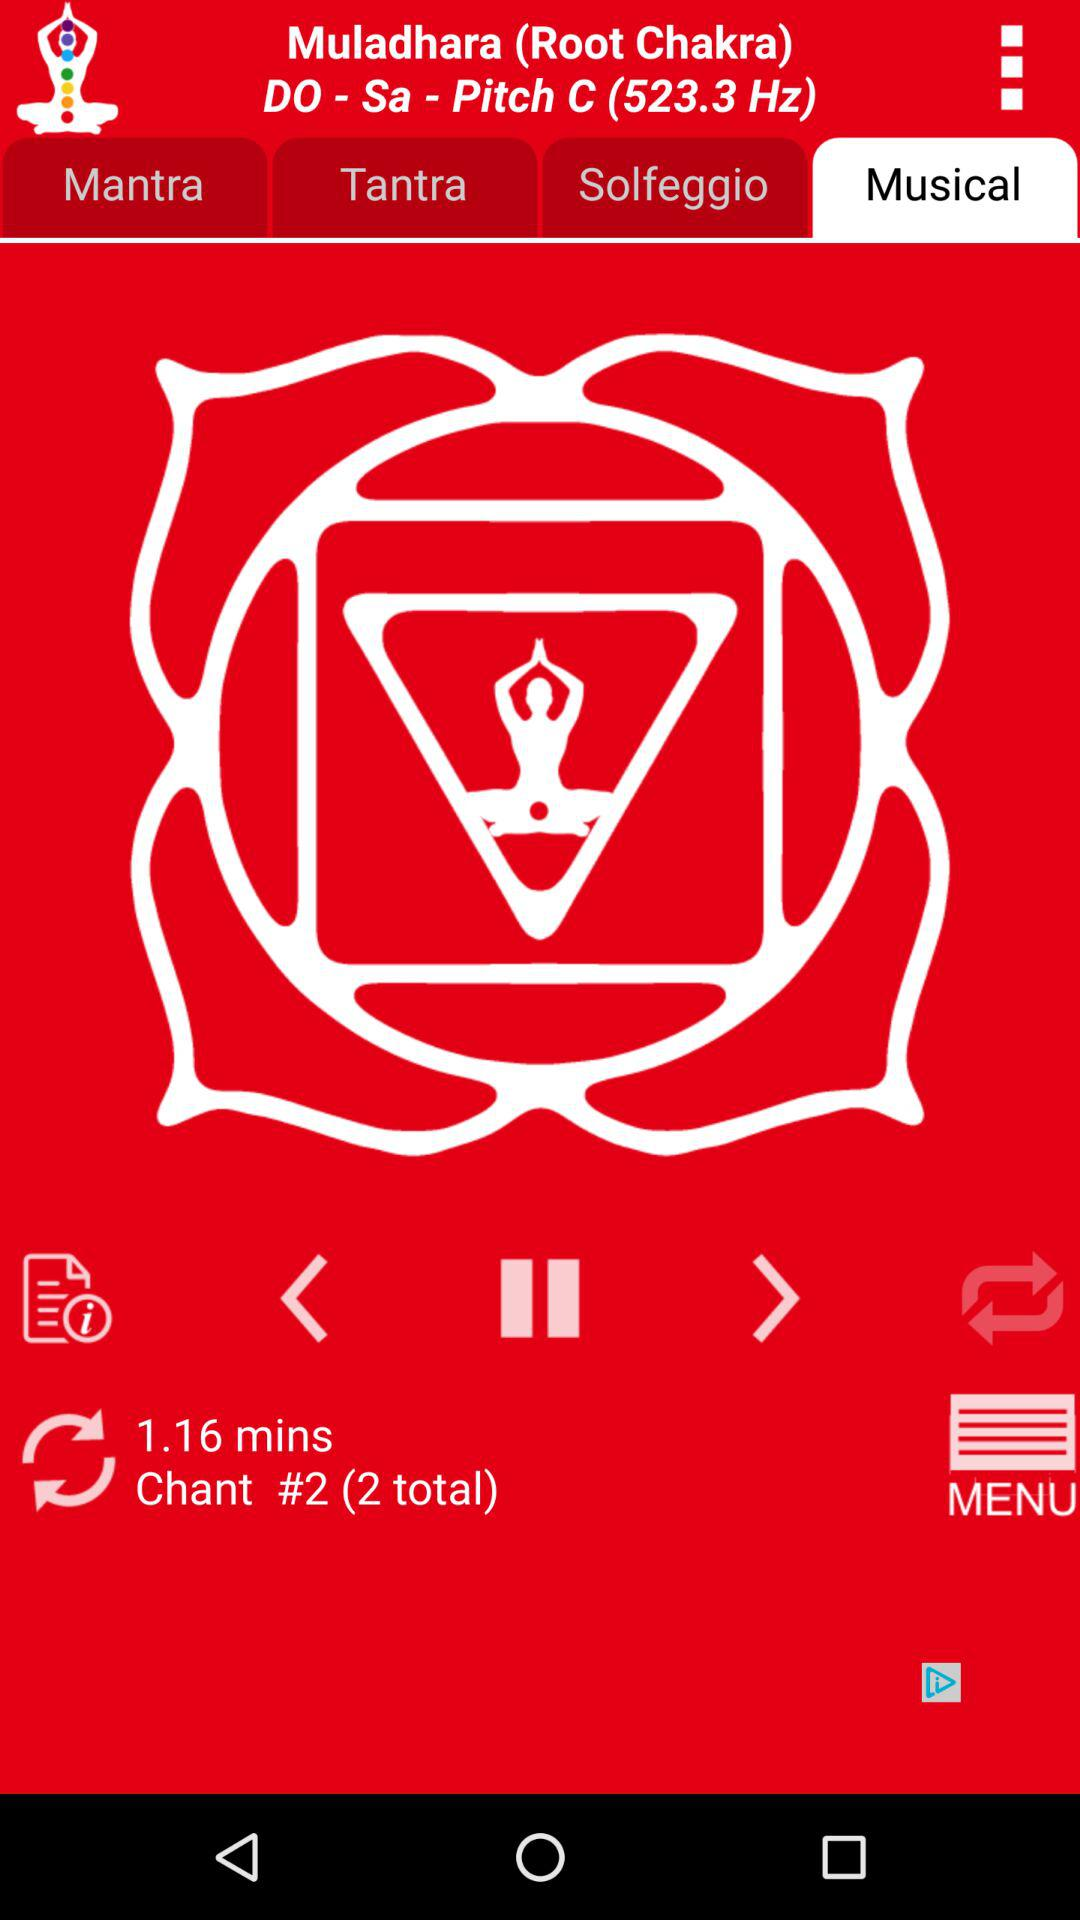How many chants are there in total? There are 2 chants in total. 